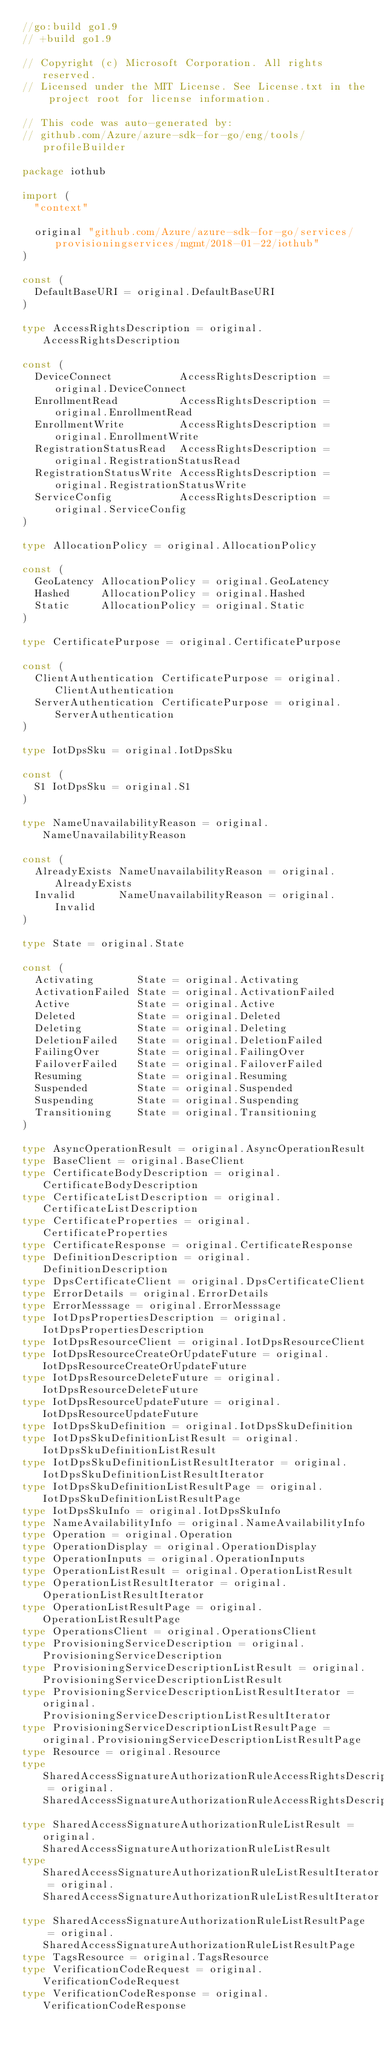<code> <loc_0><loc_0><loc_500><loc_500><_Go_>//go:build go1.9
// +build go1.9

// Copyright (c) Microsoft Corporation. All rights reserved.
// Licensed under the MIT License. See License.txt in the project root for license information.

// This code was auto-generated by:
// github.com/Azure/azure-sdk-for-go/eng/tools/profileBuilder

package iothub

import (
	"context"

	original "github.com/Azure/azure-sdk-for-go/services/provisioningservices/mgmt/2018-01-22/iothub"
)

const (
	DefaultBaseURI = original.DefaultBaseURI
)

type AccessRightsDescription = original.AccessRightsDescription

const (
	DeviceConnect           AccessRightsDescription = original.DeviceConnect
	EnrollmentRead          AccessRightsDescription = original.EnrollmentRead
	EnrollmentWrite         AccessRightsDescription = original.EnrollmentWrite
	RegistrationStatusRead  AccessRightsDescription = original.RegistrationStatusRead
	RegistrationStatusWrite AccessRightsDescription = original.RegistrationStatusWrite
	ServiceConfig           AccessRightsDescription = original.ServiceConfig
)

type AllocationPolicy = original.AllocationPolicy

const (
	GeoLatency AllocationPolicy = original.GeoLatency
	Hashed     AllocationPolicy = original.Hashed
	Static     AllocationPolicy = original.Static
)

type CertificatePurpose = original.CertificatePurpose

const (
	ClientAuthentication CertificatePurpose = original.ClientAuthentication
	ServerAuthentication CertificatePurpose = original.ServerAuthentication
)

type IotDpsSku = original.IotDpsSku

const (
	S1 IotDpsSku = original.S1
)

type NameUnavailabilityReason = original.NameUnavailabilityReason

const (
	AlreadyExists NameUnavailabilityReason = original.AlreadyExists
	Invalid       NameUnavailabilityReason = original.Invalid
)

type State = original.State

const (
	Activating       State = original.Activating
	ActivationFailed State = original.ActivationFailed
	Active           State = original.Active
	Deleted          State = original.Deleted
	Deleting         State = original.Deleting
	DeletionFailed   State = original.DeletionFailed
	FailingOver      State = original.FailingOver
	FailoverFailed   State = original.FailoverFailed
	Resuming         State = original.Resuming
	Suspended        State = original.Suspended
	Suspending       State = original.Suspending
	Transitioning    State = original.Transitioning
)

type AsyncOperationResult = original.AsyncOperationResult
type BaseClient = original.BaseClient
type CertificateBodyDescription = original.CertificateBodyDescription
type CertificateListDescription = original.CertificateListDescription
type CertificateProperties = original.CertificateProperties
type CertificateResponse = original.CertificateResponse
type DefinitionDescription = original.DefinitionDescription
type DpsCertificateClient = original.DpsCertificateClient
type ErrorDetails = original.ErrorDetails
type ErrorMesssage = original.ErrorMesssage
type IotDpsPropertiesDescription = original.IotDpsPropertiesDescription
type IotDpsResourceClient = original.IotDpsResourceClient
type IotDpsResourceCreateOrUpdateFuture = original.IotDpsResourceCreateOrUpdateFuture
type IotDpsResourceDeleteFuture = original.IotDpsResourceDeleteFuture
type IotDpsResourceUpdateFuture = original.IotDpsResourceUpdateFuture
type IotDpsSkuDefinition = original.IotDpsSkuDefinition
type IotDpsSkuDefinitionListResult = original.IotDpsSkuDefinitionListResult
type IotDpsSkuDefinitionListResultIterator = original.IotDpsSkuDefinitionListResultIterator
type IotDpsSkuDefinitionListResultPage = original.IotDpsSkuDefinitionListResultPage
type IotDpsSkuInfo = original.IotDpsSkuInfo
type NameAvailabilityInfo = original.NameAvailabilityInfo
type Operation = original.Operation
type OperationDisplay = original.OperationDisplay
type OperationInputs = original.OperationInputs
type OperationListResult = original.OperationListResult
type OperationListResultIterator = original.OperationListResultIterator
type OperationListResultPage = original.OperationListResultPage
type OperationsClient = original.OperationsClient
type ProvisioningServiceDescription = original.ProvisioningServiceDescription
type ProvisioningServiceDescriptionListResult = original.ProvisioningServiceDescriptionListResult
type ProvisioningServiceDescriptionListResultIterator = original.ProvisioningServiceDescriptionListResultIterator
type ProvisioningServiceDescriptionListResultPage = original.ProvisioningServiceDescriptionListResultPage
type Resource = original.Resource
type SharedAccessSignatureAuthorizationRuleAccessRightsDescription = original.SharedAccessSignatureAuthorizationRuleAccessRightsDescription
type SharedAccessSignatureAuthorizationRuleListResult = original.SharedAccessSignatureAuthorizationRuleListResult
type SharedAccessSignatureAuthorizationRuleListResultIterator = original.SharedAccessSignatureAuthorizationRuleListResultIterator
type SharedAccessSignatureAuthorizationRuleListResultPage = original.SharedAccessSignatureAuthorizationRuleListResultPage
type TagsResource = original.TagsResource
type VerificationCodeRequest = original.VerificationCodeRequest
type VerificationCodeResponse = original.VerificationCodeResponse</code> 